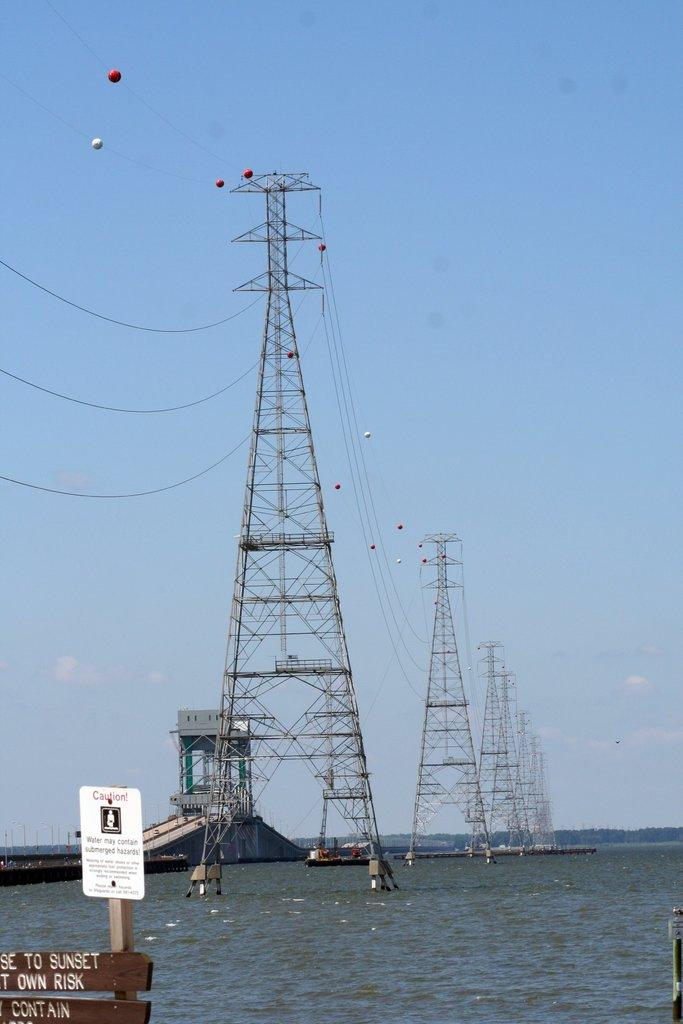What objects are present in the image? There are boards in the image. What can be seen in the background of the image? In the background, there is water, a bridge, a boat, power towers, and the sky. Can you describe the bridge in the background? The bridge is visible in the background of the image. What type of structure is present near the water? There is a boat in the background of the image. What else can be seen in the sky? The sky is visible in the background of the image. How many dogs are visible on the boat in the image? There are no dogs present in the image; it features a boat in the background. What type of calculator can be seen on the bridge in the image? There is no calculator present in the image; it features a bridge in the background. 